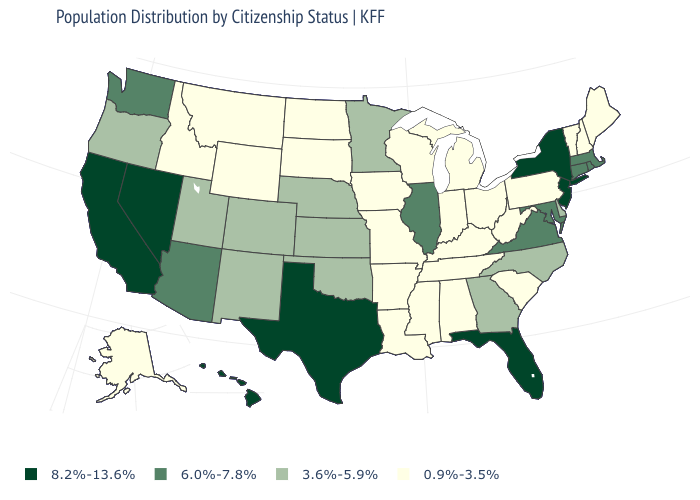What is the value of Washington?
Write a very short answer. 6.0%-7.8%. What is the value of Wyoming?
Give a very brief answer. 0.9%-3.5%. Does Nevada have the same value as Florida?
Be succinct. Yes. What is the value of Alabama?
Quick response, please. 0.9%-3.5%. What is the highest value in the USA?
Give a very brief answer. 8.2%-13.6%. Name the states that have a value in the range 6.0%-7.8%?
Quick response, please. Arizona, Connecticut, Illinois, Maryland, Massachusetts, Rhode Island, Virginia, Washington. Does Connecticut have the highest value in the USA?
Answer briefly. No. Which states have the highest value in the USA?
Give a very brief answer. California, Florida, Hawaii, Nevada, New Jersey, New York, Texas. What is the value of South Dakota?
Be succinct. 0.9%-3.5%. What is the value of Florida?
Give a very brief answer. 8.2%-13.6%. Which states have the lowest value in the MidWest?
Be succinct. Indiana, Iowa, Michigan, Missouri, North Dakota, Ohio, South Dakota, Wisconsin. What is the lowest value in the West?
Answer briefly. 0.9%-3.5%. What is the value of Mississippi?
Write a very short answer. 0.9%-3.5%. Name the states that have a value in the range 3.6%-5.9%?
Quick response, please. Colorado, Delaware, Georgia, Kansas, Minnesota, Nebraska, New Mexico, North Carolina, Oklahoma, Oregon, Utah. What is the value of Utah?
Keep it brief. 3.6%-5.9%. 